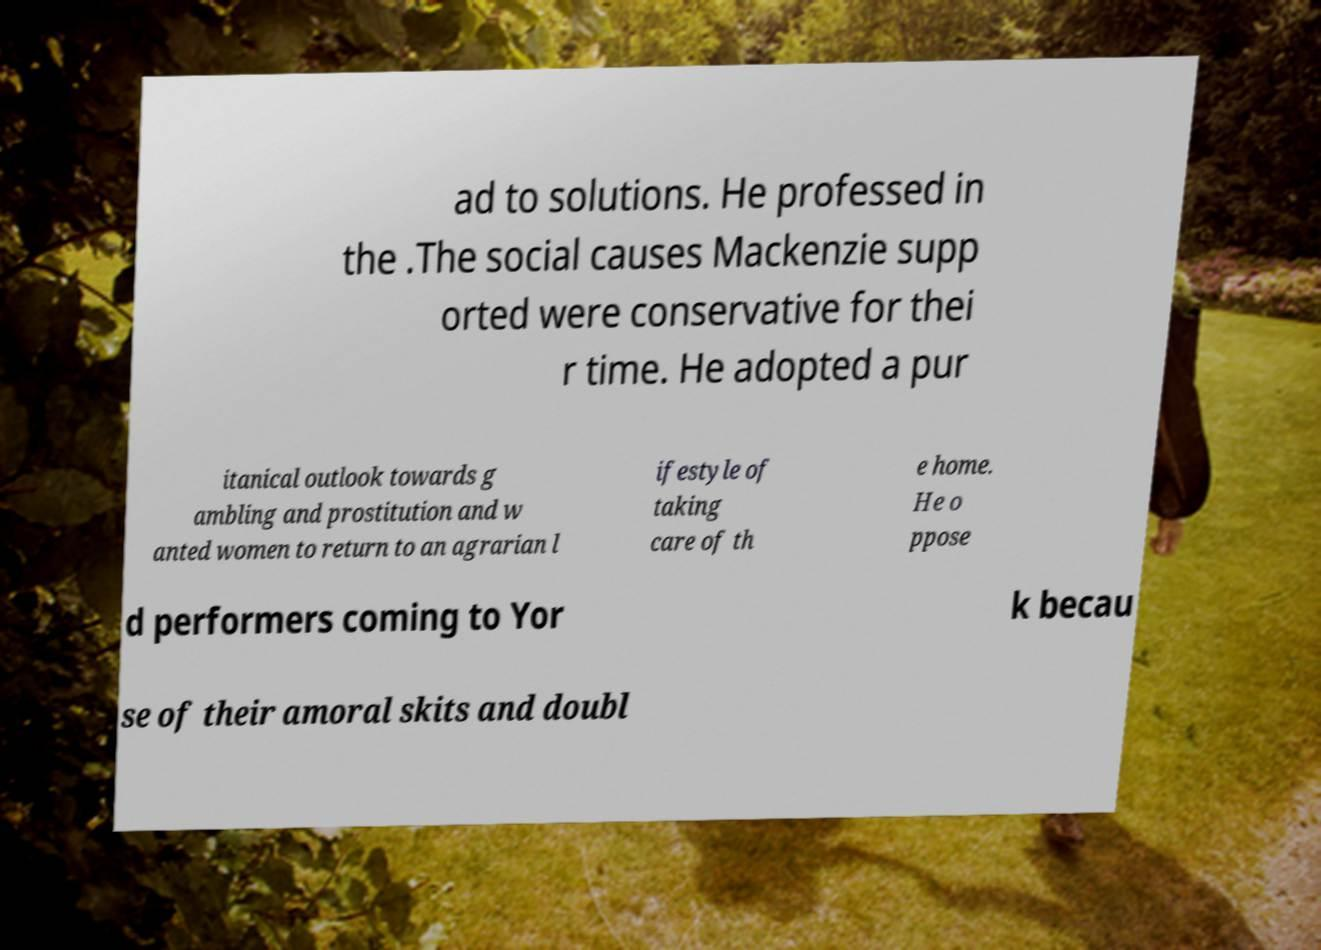Please identify and transcribe the text found in this image. ad to solutions. He professed in the .The social causes Mackenzie supp orted were conservative for thei r time. He adopted a pur itanical outlook towards g ambling and prostitution and w anted women to return to an agrarian l ifestyle of taking care of th e home. He o ppose d performers coming to Yor k becau se of their amoral skits and doubl 